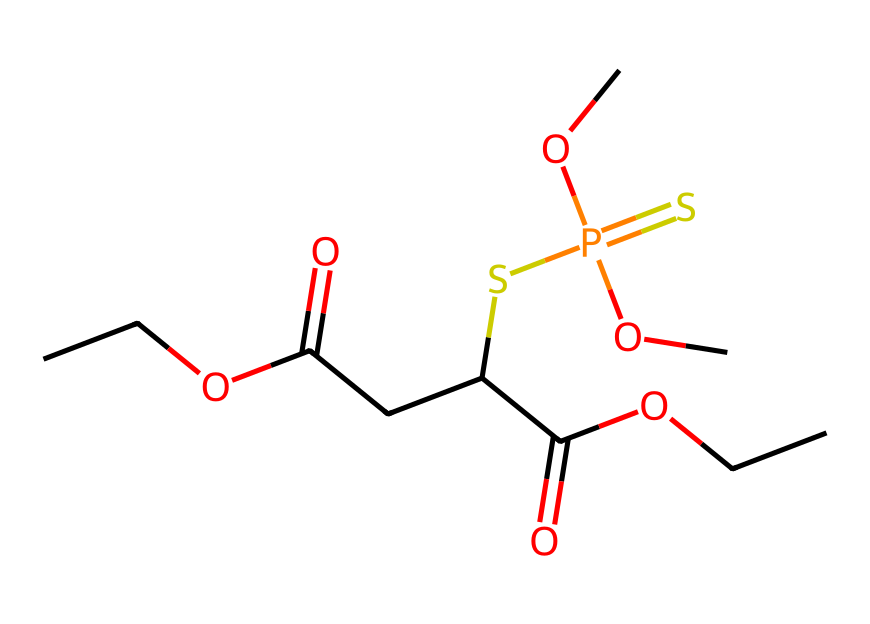What is the IUPAC name of the pesticide shown in the structure? The SMILES representation indicates the structure of malathion, which is a well-known pesticide. The IUPAC name directly corresponds to this common name.
Answer: malathion How many carbon atoms are present in this chemical structure? By analyzing the SMILES representation, we count the carbon atoms as follows: there are 8 'C' notations present in the structure, indicating 8 carbon atoms.
Answer: 8 What functional groups are present in malathion? The structure reveals multiple functional groups: an ester (C(=O)OC), a carboxylic acid (C(=O)O), and a phosphorothioate group (SP(=S)(OC)OC). Identifying these parts confirms the functional groups present in malathion.
Answer: ester, carboxylic acid, phosphorothioate What is the primary use of malathion as a pesticide? Malathion is primarily used for controlling insect populations, especially in mosquito control programs, which is evident from its usage in public health contexts.
Answer: mosquito control How many oxygen atoms are there in the structure of malathion? In the given SMILES, we observe 'O' appears five times, indicating the presence of 5 oxygen atoms in malathion's structure.
Answer: 5 What distinguishes malathion as an organophosphate pesticide? Malathion contains a phosphorus atom (P) which is characteristic of organophosphate pesticides. The presence of the phosphorothioate group (SP(=S)OC) confirms its classification in this category.
Answer: phosphorus atom 